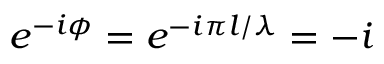<formula> <loc_0><loc_0><loc_500><loc_500>e ^ { - i \phi } = e ^ { - i \pi l / \lambda } = - i</formula> 